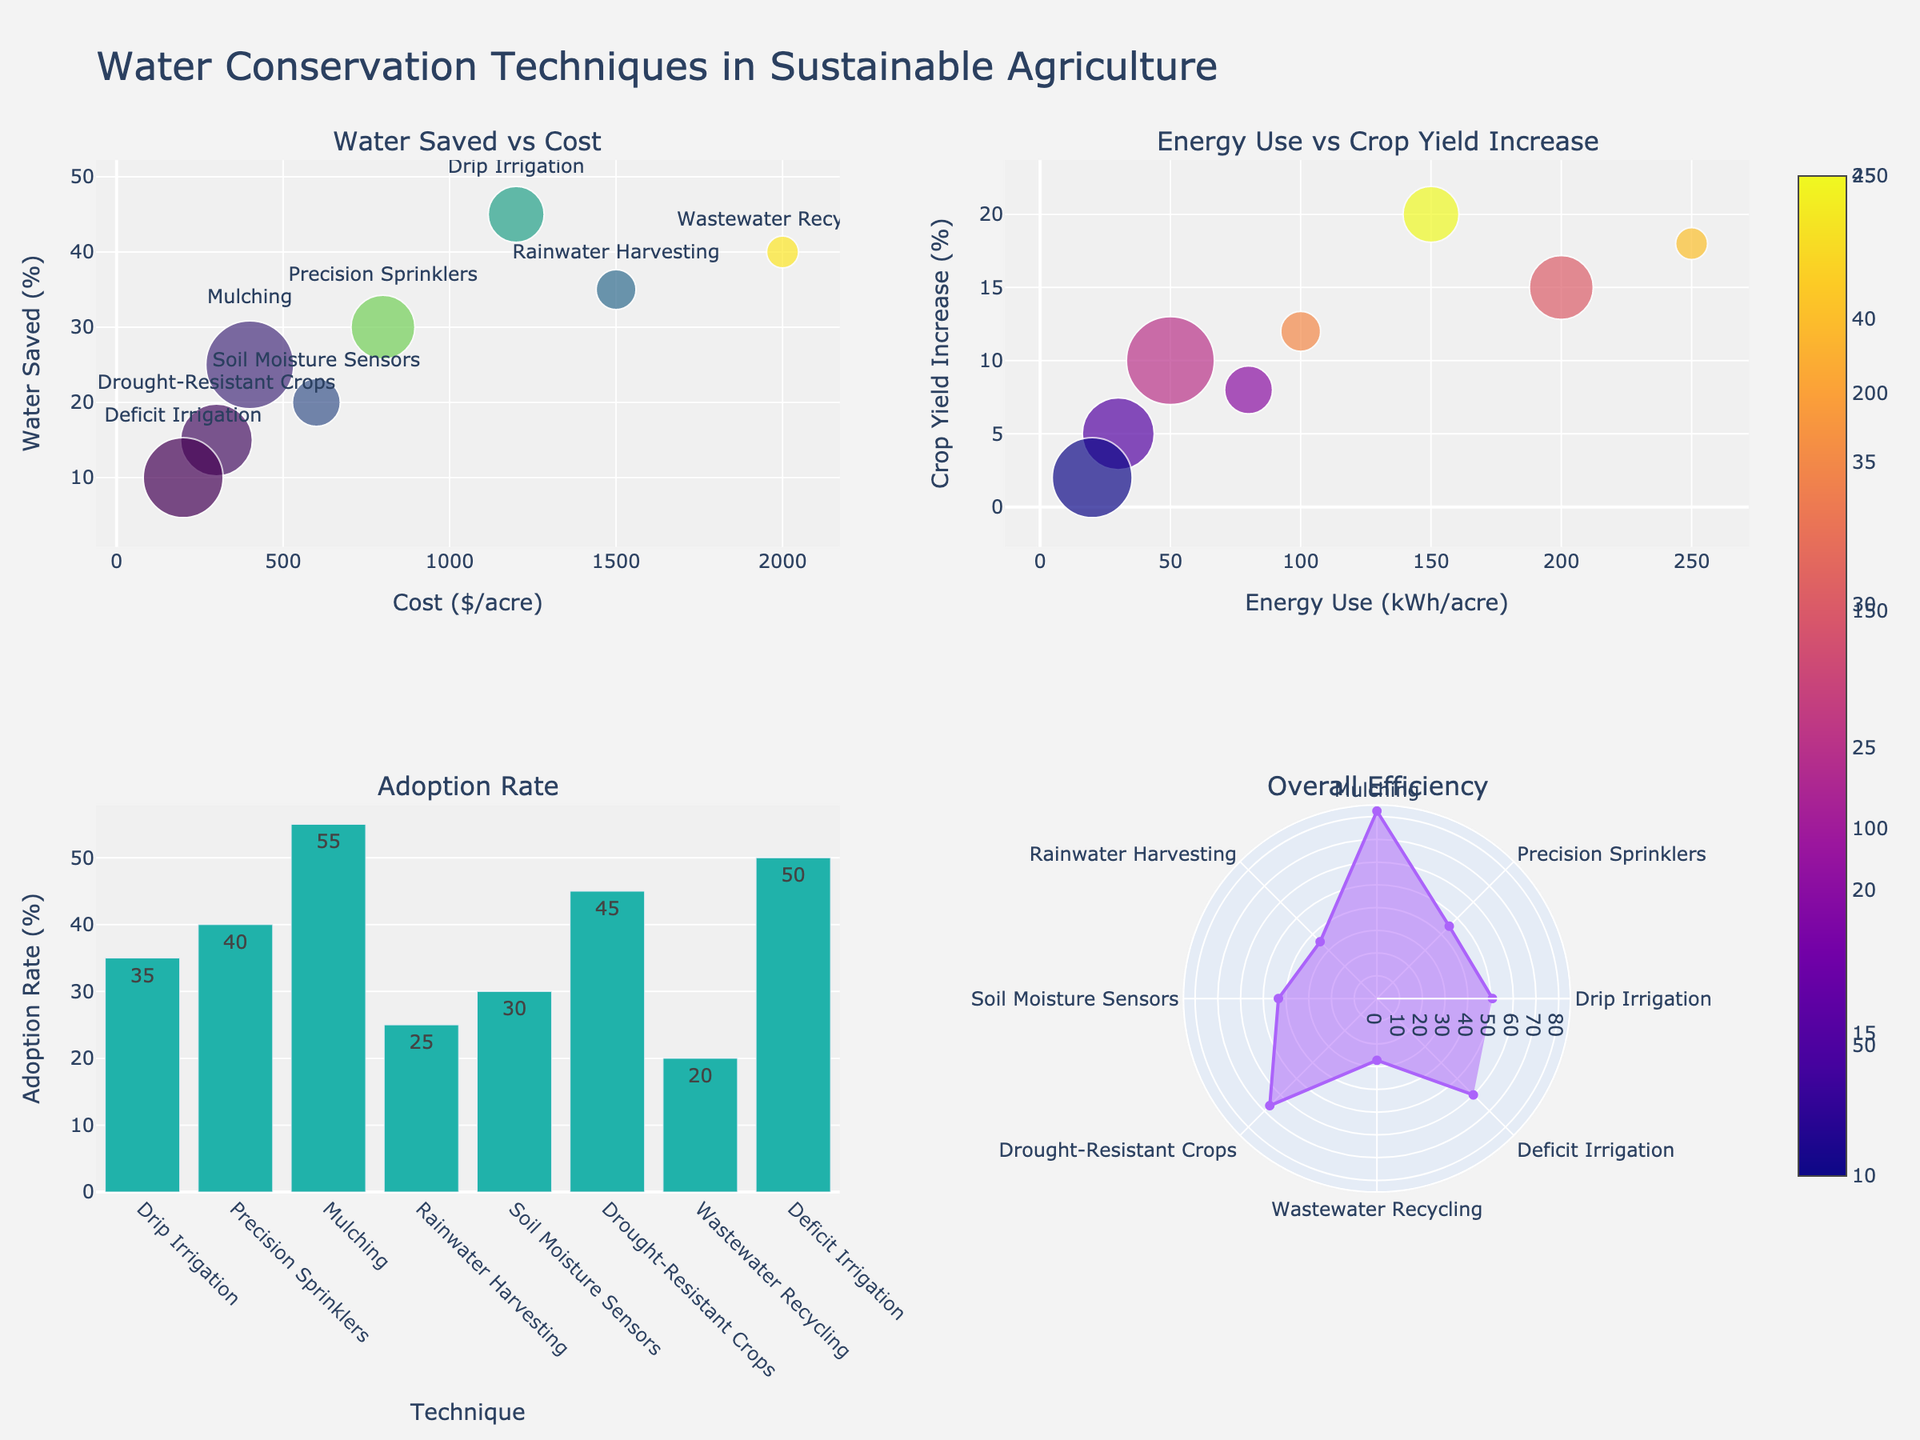Which technique has the highest adoption rate? From the bar chart, the tallest bar represents the technique with the highest adoption rate. Observing the chart, Deficit Irrigation has the tallest bar.
Answer: Deficit Irrigation What is the cost per acre for Rainwater Harvesting? The scatter plots show the cost on the x-axis for Water Saved vs Cost. The technique Rainwater Harvesting aligns with a cost value of 1500 on the x-axis.
Answer: 1500 Which technique yields the highest percentage increase in crop yield? Check the second scatter plot showing Energy Use vs Crop Yield Increase. The technique that has the highest point on the y-axis will represent the highest crop yield increase. Drip Irrigation has the highest point on the y-axis.
Answer: Drip Irrigation Which technique has the lowest water saving percentage? Refer to the water saved aspect in the first scatter plot, where the lowest point on the y-axis represents the least water saving. Deficit Irrigation is at the lowest position on the y-axis.
Answer: Deficit Irrigation Compare the adoption rates of Drought-Resistant Crops and Mulching. Which is higher? In the bar chart showing Adoption Rate, note the heights of the bars for Drought-Resistant Crops and Mulching. Mulching has a higher bar indicating a higher adoption rate.
Answer: Mulching What is the efficiency score for Drip Irrigation compared to Precision Sprinklers? Review the polar chart, which calculates efficiency scores based on a specific formula. Drip Irrigation has a higher radius than Precision Sprinklers, representing a higher efficiency score.
Answer: Drip Irrigation How does the energy use of Wastewater Recycling compare to Soil Moisture Sensors? In the second scatter plot with Energy Use on the x-axis, compare the positions of Wastewater Recycling and Soil Moisture Sensors along the x-axis. Wastewater Recycling has a higher value on the x-axis for energy use.
Answer: Wastewater Recycling Which technique has a moderate adoption rate but significant cost per acre? From the bar chart for Adoption Rate, identify techniques around mid-height, then cross-reference with the scatter plot for high-cost points. Rainwater Harvesting is moderate in adoption and high in cost.
Answer: Rainwater Harvesting Which technique has the smallest adoption rate but high water saving? Looking at the bar chart and first scatter plot, identify the smallest bar and high point on y-axis (Water Saved). Wastewater Recycling fits this description: low adoption and high water saving.
Answer: Wastewater Recycling What relationship can you observe between cost and water saved in drip irrigation? Viewing the first scatter plot, Drip Irrigation is plotted at a high y-value (water saved) and moderate x-value (cost), suggesting high water savings with moderate financial investment.
Answer: High water savings, moderate cost 